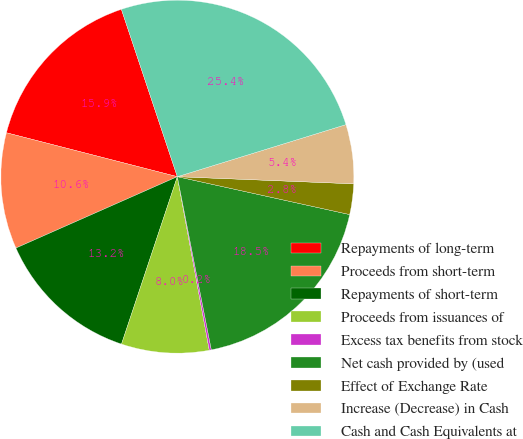Convert chart to OTSL. <chart><loc_0><loc_0><loc_500><loc_500><pie_chart><fcel>Repayments of long-term<fcel>Proceeds from short-term<fcel>Repayments of short-term<fcel>Proceeds from issuances of<fcel>Excess tax benefits from stock<fcel>Net cash provided by (used<fcel>Effect of Exchange Rate<fcel>Increase (Decrease) in Cash<fcel>Cash and Cash Equivalents at<nl><fcel>15.86%<fcel>10.63%<fcel>13.25%<fcel>8.02%<fcel>0.19%<fcel>18.47%<fcel>2.8%<fcel>5.41%<fcel>25.37%<nl></chart> 